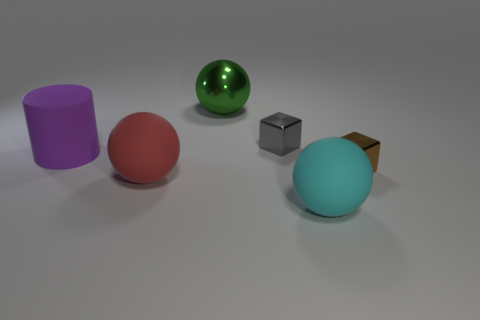Add 1 large cyan matte cylinders. How many objects exist? 7 Subtract all rubber spheres. How many spheres are left? 1 Subtract all cylinders. How many objects are left? 5 Subtract all brown cubes. How many cubes are left? 1 Subtract 1 spheres. How many spheres are left? 2 Subtract all brown cubes. Subtract all cyan cylinders. How many cubes are left? 1 Subtract all brown cubes. Subtract all purple cylinders. How many objects are left? 4 Add 4 big green metallic spheres. How many big green metallic spheres are left? 5 Add 5 small brown rubber cubes. How many small brown rubber cubes exist? 5 Subtract 0 cyan cylinders. How many objects are left? 6 